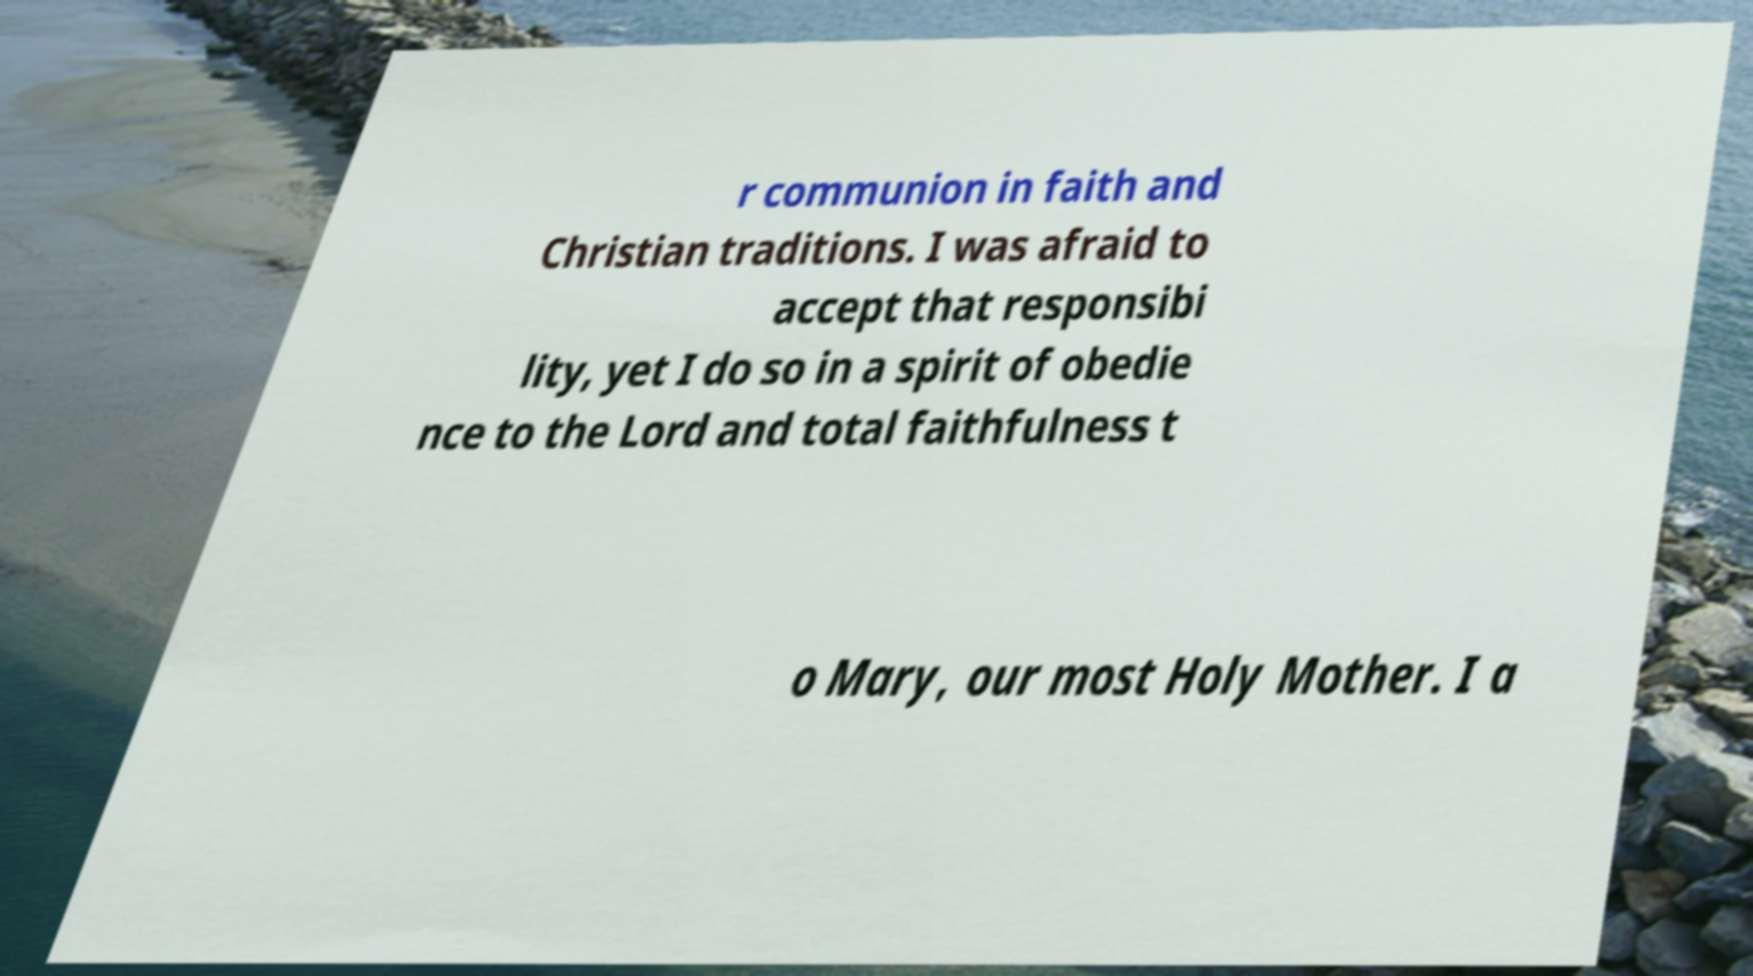Please read and relay the text visible in this image. What does it say? r communion in faith and Christian traditions. I was afraid to accept that responsibi lity, yet I do so in a spirit of obedie nce to the Lord and total faithfulness t o Mary, our most Holy Mother. I a 